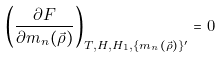Convert formula to latex. <formula><loc_0><loc_0><loc_500><loc_500>\left ( \frac { \partial F } { \partial m _ { n } ( \vec { \rho } ) } \right ) _ { T , H , H _ { 1 } , \{ m _ { n } ( \vec { \rho } ) \} ^ { \prime } } = 0</formula> 